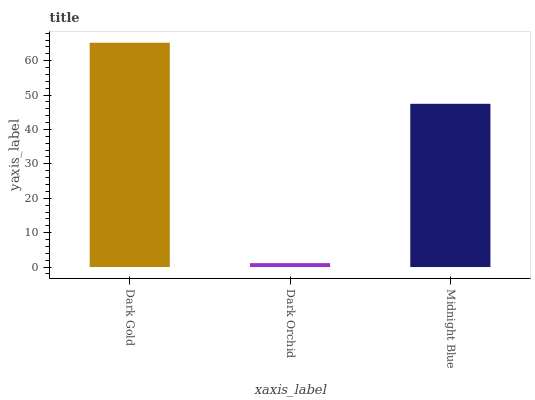Is Dark Orchid the minimum?
Answer yes or no. Yes. Is Dark Gold the maximum?
Answer yes or no. Yes. Is Midnight Blue the minimum?
Answer yes or no. No. Is Midnight Blue the maximum?
Answer yes or no. No. Is Midnight Blue greater than Dark Orchid?
Answer yes or no. Yes. Is Dark Orchid less than Midnight Blue?
Answer yes or no. Yes. Is Dark Orchid greater than Midnight Blue?
Answer yes or no. No. Is Midnight Blue less than Dark Orchid?
Answer yes or no. No. Is Midnight Blue the high median?
Answer yes or no. Yes. Is Midnight Blue the low median?
Answer yes or no. Yes. Is Dark Gold the high median?
Answer yes or no. No. Is Dark Orchid the low median?
Answer yes or no. No. 